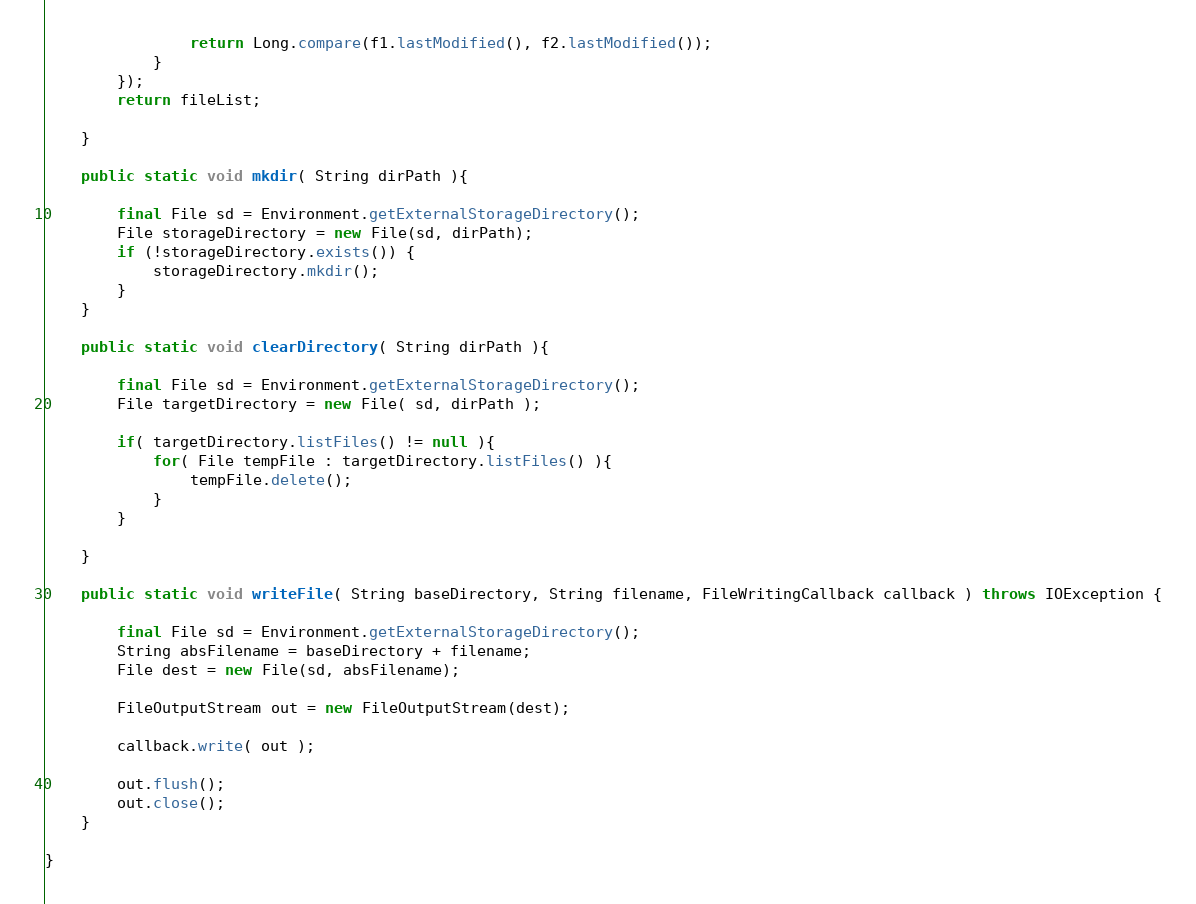<code> <loc_0><loc_0><loc_500><loc_500><_Java_>                return Long.compare(f1.lastModified(), f2.lastModified());
            }
        });
        return fileList;

    }

    public static void mkdir( String dirPath ){

        final File sd = Environment.getExternalStorageDirectory();
        File storageDirectory = new File(sd, dirPath);
        if (!storageDirectory.exists()) {
            storageDirectory.mkdir();
        }
    }

    public static void clearDirectory( String dirPath ){

        final File sd = Environment.getExternalStorageDirectory();
        File targetDirectory = new File( sd, dirPath );

        if( targetDirectory.listFiles() != null ){
            for( File tempFile : targetDirectory.listFiles() ){
                tempFile.delete();
            }
        }

    }

    public static void writeFile( String baseDirectory, String filename, FileWritingCallback callback ) throws IOException {

        final File sd = Environment.getExternalStorageDirectory();
        String absFilename = baseDirectory + filename;
        File dest = new File(sd, absFilename);

        FileOutputStream out = new FileOutputStream(dest);

        callback.write( out );

        out.flush();
        out.close();
    }

}
</code> 